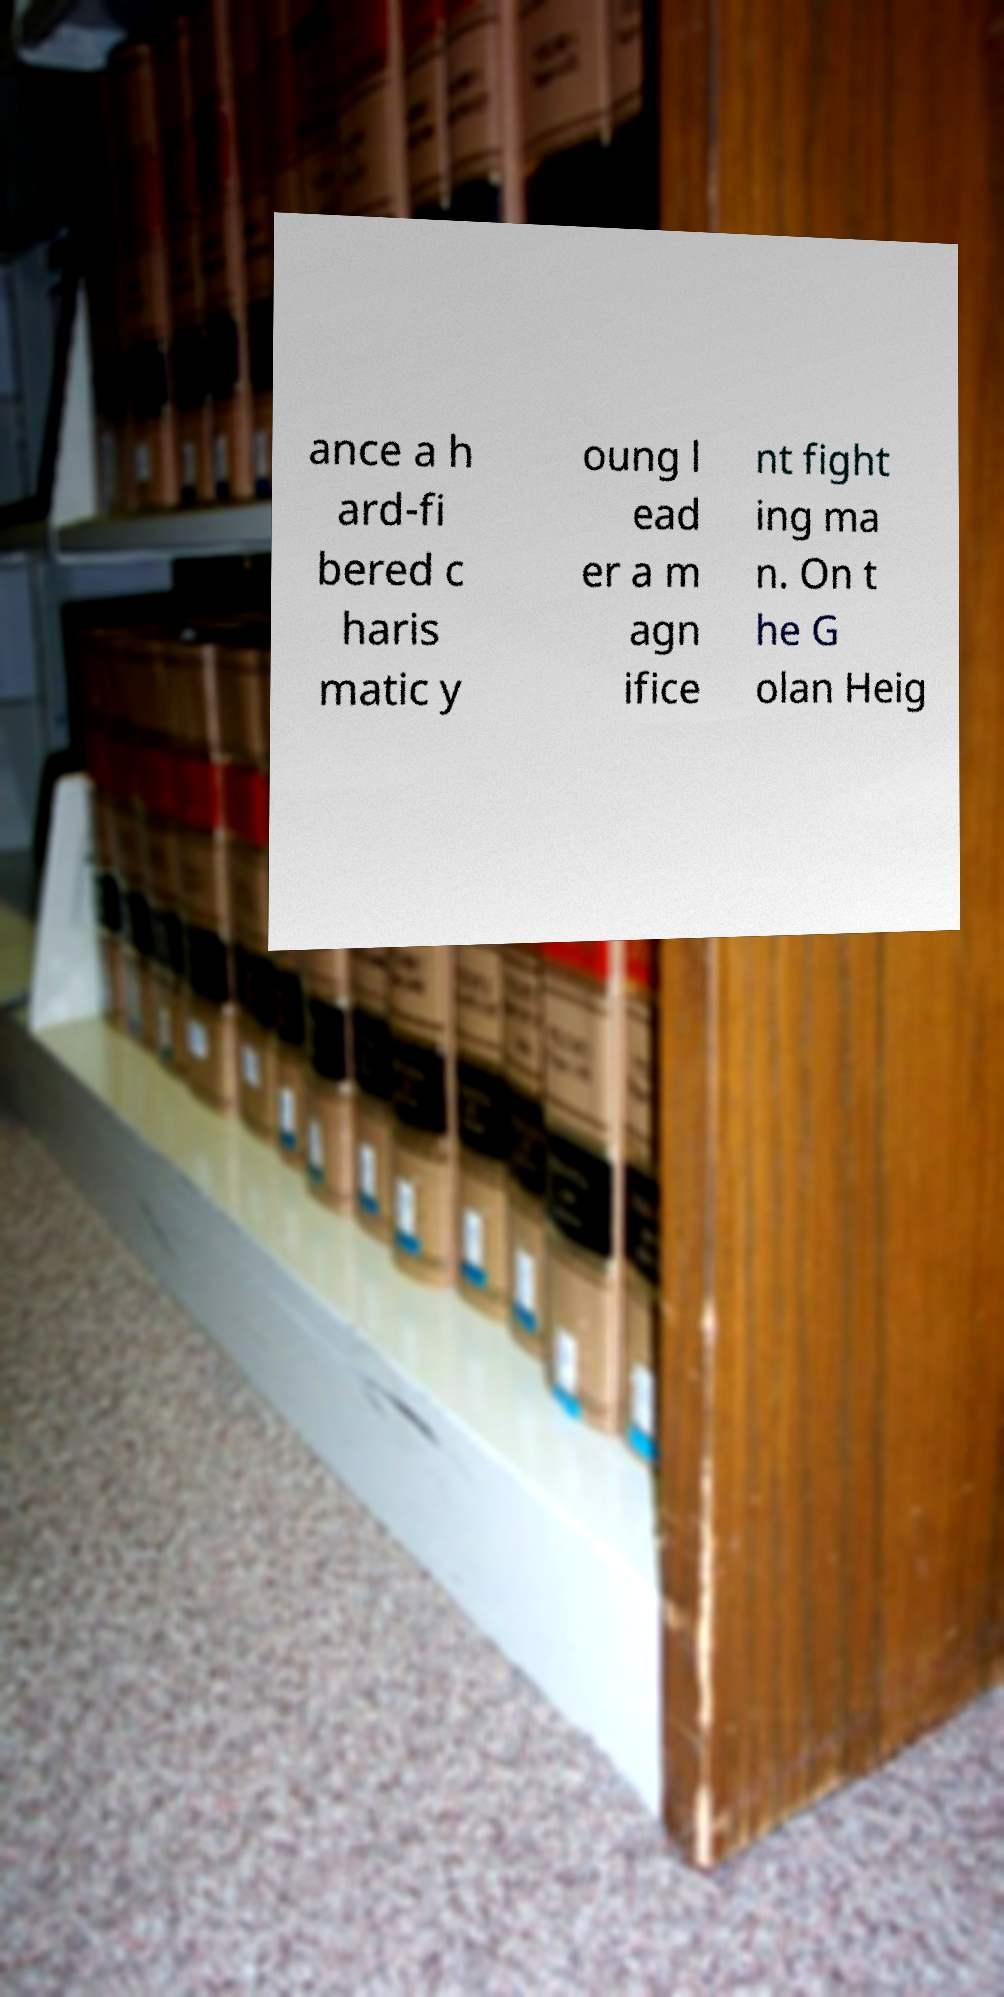Could you assist in decoding the text presented in this image and type it out clearly? ance a h ard-fi bered c haris matic y oung l ead er a m agn ifice nt fight ing ma n. On t he G olan Heig 